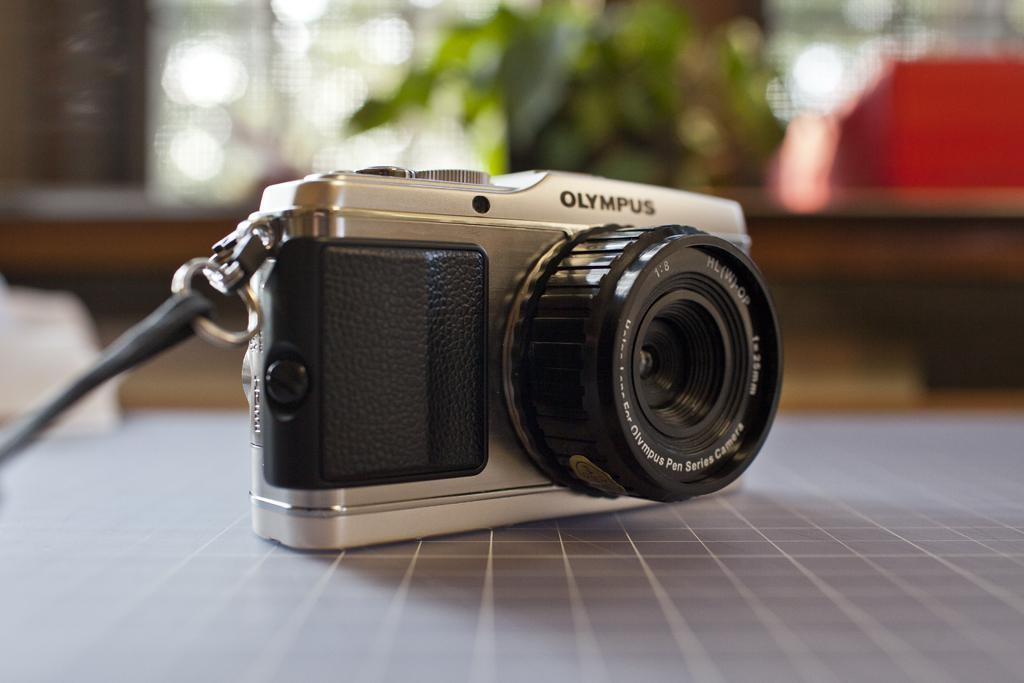What object is the main subject of the image? There is a camera in the image. Are there any words or letters on the camera? Yes, the camera has text on it. On what surface is the camera placed? The camera is placed on a surface that resembles a table. How would you describe the background of the image? The background of the image is blurred. Can you tell me how many sails are visible in the image? There are no sails present in the image; it features a camera with text on it. What type of pest can be seen crawling on the camera in the image? There is no pest visible on the camera in the image. 